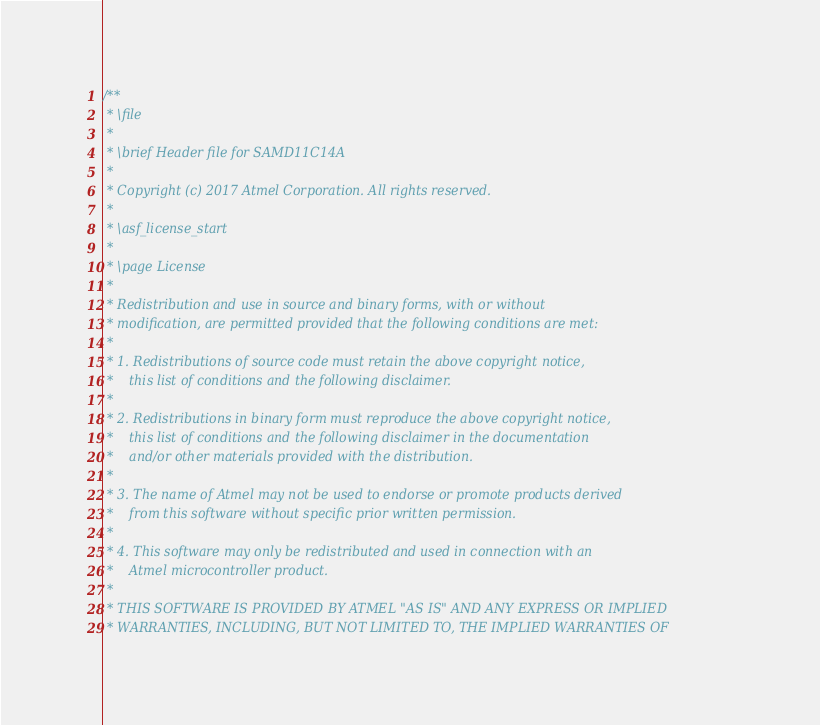<code> <loc_0><loc_0><loc_500><loc_500><_C_>/**
 * \file
 *
 * \brief Header file for SAMD11C14A
 *
 * Copyright (c) 2017 Atmel Corporation. All rights reserved.
 *
 * \asf_license_start
 *
 * \page License
 *
 * Redistribution and use in source and binary forms, with or without
 * modification, are permitted provided that the following conditions are met:
 *
 * 1. Redistributions of source code must retain the above copyright notice,
 *    this list of conditions and the following disclaimer.
 *
 * 2. Redistributions in binary form must reproduce the above copyright notice,
 *    this list of conditions and the following disclaimer in the documentation
 *    and/or other materials provided with the distribution.
 *
 * 3. The name of Atmel may not be used to endorse or promote products derived
 *    from this software without specific prior written permission.
 *
 * 4. This software may only be redistributed and used in connection with an
 *    Atmel microcontroller product.
 *
 * THIS SOFTWARE IS PROVIDED BY ATMEL "AS IS" AND ANY EXPRESS OR IMPLIED
 * WARRANTIES, INCLUDING, BUT NOT LIMITED TO, THE IMPLIED WARRANTIES OF</code> 